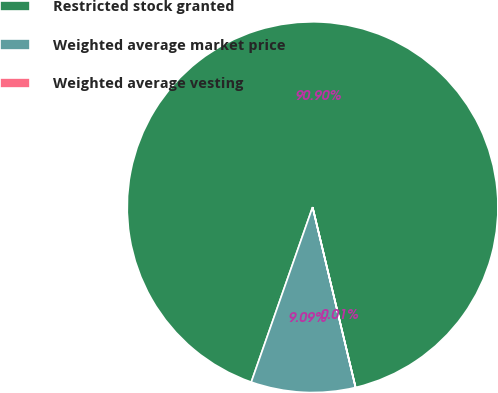Convert chart to OTSL. <chart><loc_0><loc_0><loc_500><loc_500><pie_chart><fcel>Restricted stock granted<fcel>Weighted average market price<fcel>Weighted average vesting<nl><fcel>90.9%<fcel>9.09%<fcel>0.01%<nl></chart> 